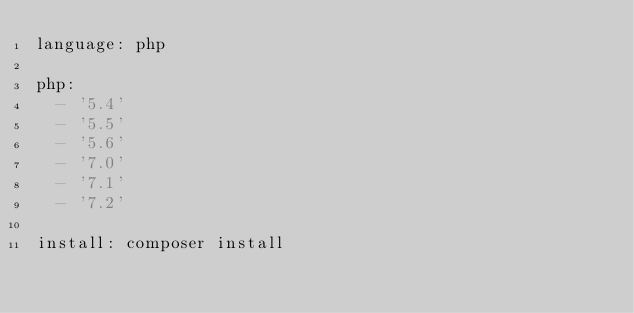Convert code to text. <code><loc_0><loc_0><loc_500><loc_500><_YAML_>language: php

php:
  - '5.4'
  - '5.5'
  - '5.6'
  - '7.0'
  - '7.1'
  - '7.2'

install: composer install</code> 